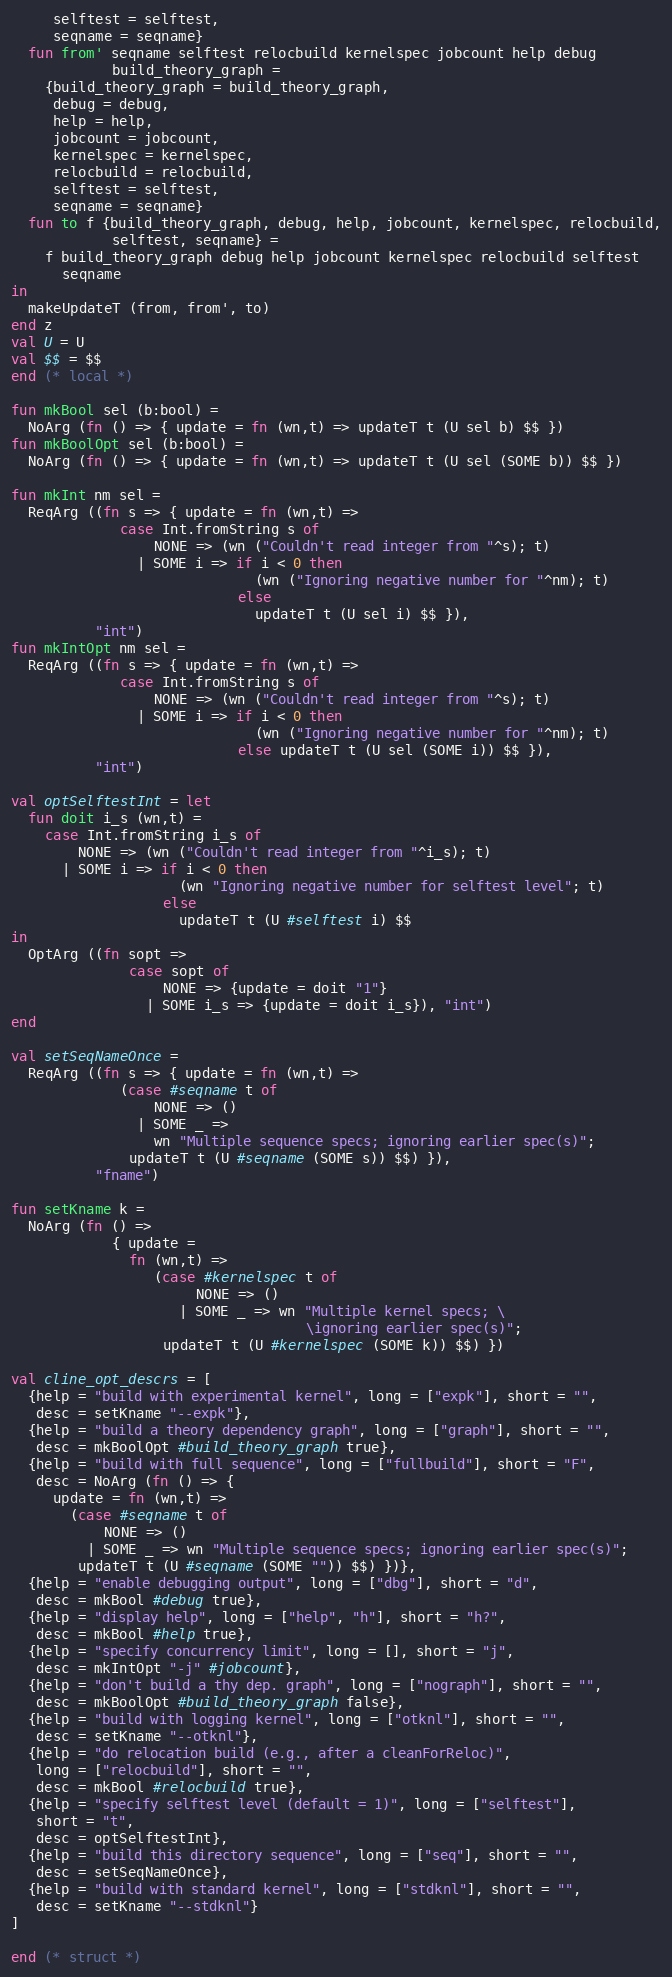Convert code to text. <code><loc_0><loc_0><loc_500><loc_500><_SML_>     selftest = selftest,
     seqname = seqname}
  fun from' seqname selftest relocbuild kernelspec jobcount help debug
            build_theory_graph =
    {build_theory_graph = build_theory_graph,
     debug = debug,
     help = help,
     jobcount = jobcount,
     kernelspec = kernelspec,
     relocbuild = relocbuild,
     selftest = selftest,
     seqname = seqname}
  fun to f {build_theory_graph, debug, help, jobcount, kernelspec, relocbuild,
            selftest, seqname} =
    f build_theory_graph debug help jobcount kernelspec relocbuild selftest
      seqname
in
  makeUpdateT (from, from', to)
end z
val U = U
val $$ = $$
end (* local *)

fun mkBool sel (b:bool) =
  NoArg (fn () => { update = fn (wn,t) => updateT t (U sel b) $$ })
fun mkBoolOpt sel (b:bool) =
  NoArg (fn () => { update = fn (wn,t) => updateT t (U sel (SOME b)) $$ })

fun mkInt nm sel =
  ReqArg ((fn s => { update = fn (wn,t) =>
             case Int.fromString s of
                 NONE => (wn ("Couldn't read integer from "^s); t)
               | SOME i => if i < 0 then
                             (wn ("Ignoring negative number for "^nm); t)
                           else
                             updateT t (U sel i) $$ }),
          "int")
fun mkIntOpt nm sel =
  ReqArg ((fn s => { update = fn (wn,t) =>
             case Int.fromString s of
                 NONE => (wn ("Couldn't read integer from "^s); t)
               | SOME i => if i < 0 then
                             (wn ("Ignoring negative number for "^nm); t)
                           else updateT t (U sel (SOME i)) $$ }),
          "int")

val optSelftestInt = let
  fun doit i_s (wn,t) =
    case Int.fromString i_s of
        NONE => (wn ("Couldn't read integer from "^i_s); t)
      | SOME i => if i < 0 then
                    (wn "Ignoring negative number for selftest level"; t)
                  else
                    updateT t (U #selftest i) $$
in
  OptArg ((fn sopt =>
              case sopt of
                  NONE => {update = doit "1"}
                | SOME i_s => {update = doit i_s}), "int")
end

val setSeqNameOnce =
  ReqArg ((fn s => { update = fn (wn,t) =>
             (case #seqname t of
                 NONE => ()
               | SOME _ =>
                 wn "Multiple sequence specs; ignoring earlier spec(s)";
              updateT t (U #seqname (SOME s)) $$) }),
          "fname")

fun setKname k =
  NoArg (fn () =>
            { update =
              fn (wn,t) =>
                 (case #kernelspec t of
                      NONE => ()
                    | SOME _ => wn "Multiple kernel specs; \
                                   \ignoring earlier spec(s)";
                  updateT t (U #kernelspec (SOME k)) $$) })

val cline_opt_descrs = [
  {help = "build with experimental kernel", long = ["expk"], short = "",
   desc = setKname "--expk"},
  {help = "build a theory dependency graph", long = ["graph"], short = "",
   desc = mkBoolOpt #build_theory_graph true},
  {help = "build with full sequence", long = ["fullbuild"], short = "F",
   desc = NoArg (fn () => {
     update = fn (wn,t) =>
       (case #seqname t of
           NONE => ()
         | SOME _ => wn "Multiple sequence specs; ignoring earlier spec(s)";
        updateT t (U #seqname (SOME "")) $$) })},
  {help = "enable debugging output", long = ["dbg"], short = "d",
   desc = mkBool #debug true},
  {help = "display help", long = ["help", "h"], short = "h?",
   desc = mkBool #help true},
  {help = "specify concurrency limit", long = [], short = "j",
   desc = mkIntOpt "-j" #jobcount},
  {help = "don't build a thy dep. graph", long = ["nograph"], short = "",
   desc = mkBoolOpt #build_theory_graph false},
  {help = "build with logging kernel", long = ["otknl"], short = "",
   desc = setKname "--otknl"},
  {help = "do relocation build (e.g., after a cleanForReloc)",
   long = ["relocbuild"], short = "",
   desc = mkBool #relocbuild true},
  {help = "specify selftest level (default = 1)", long = ["selftest"],
   short = "t",
   desc = optSelftestInt},
  {help = "build this directory sequence", long = ["seq"], short = "",
   desc = setSeqNameOnce},
  {help = "build with standard kernel", long = ["stdknl"], short = "",
   desc = setKname "--stdknl"}
]

end (* struct *)
</code> 